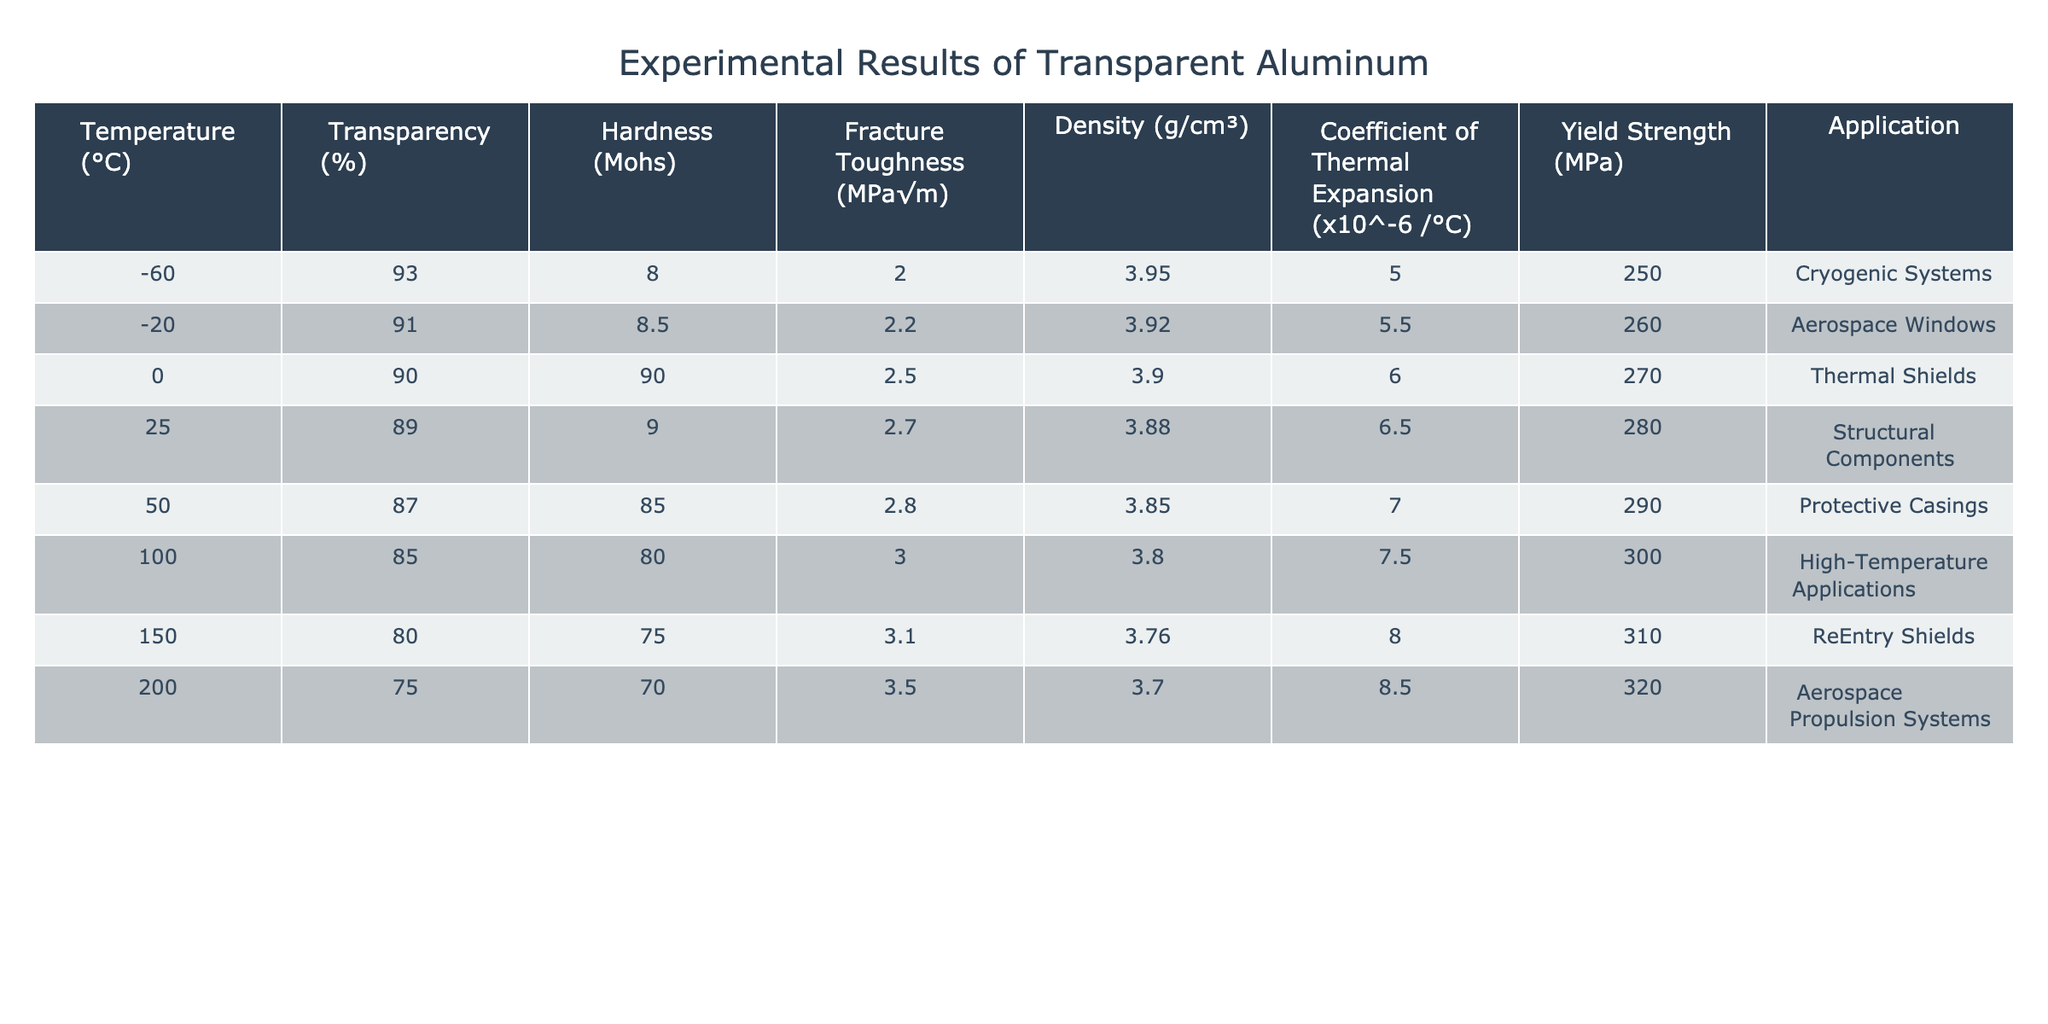What is the transparency percentage of transparent aluminum at 100°C? The table indicates that at 100°C, the transparency percentage is listed as 85%.
Answer: 85% What is the fracture toughness of transparent aluminum at -60°C? According to the table, the fracture toughness at -60°C is recorded as 2.0 MPa√m.
Answer: 2.0 MPa√m Which temperature condition yields the highest yield strength? By comparing the yield strength values at various temperatures, 200°C has the highest yield strength at 320 MPa.
Answer: 320 MPa What is the average density of transparent aluminum across all temperatures? The densities at each temperature are 3.95, 3.92, 3.90, 3.88, 3.85, 3.80, 3.76, and 3.70 g/cm³. Summing these gives 30.76 g/cm³, and dividing by 8 gives an average of 3.845 g/cm³.
Answer: 3.845 g/cm³ Does the hardness increase or decrease with rising temperature? The table shows that as the temperature increases from -60°C to 200°C, the hardness values decrease from 8 to 70. Therefore, hardness decreases with temperature.
Answer: Decreases What is the coefficient of thermal expansion at 50°C? The coefficient of thermal expansion at 50°C is listed as 7.0 x 10^-6 /°C in the table.
Answer: 7.0 x 10^-6 /°C At which temperature does the material have a transparency of 75%? The table shows that at 200°C, the transparency percentage of transparent aluminum is 75%.
Answer: 200°C What is the difference in hardness between the temperatures 0°C and 150°C? At 0°C, the hardness is 90, while at 150°C, it is 75. The difference is 90 - 75 = 15.
Answer: 15 Which temperature has the lowest transparency percentage and what is that value? At 200°C, the transparency percentage reaches its lowest value of 75% according to the table.
Answer: 75% Does transparent aluminum exhibit higher transparency at lower temperatures? Yes, the table indicates that transparency generally decreases as the temperature increases, showing higher percentages at lower temperatures.
Answer: Yes 